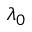Convert formula to latex. <formula><loc_0><loc_0><loc_500><loc_500>\lambda _ { 0 }</formula> 